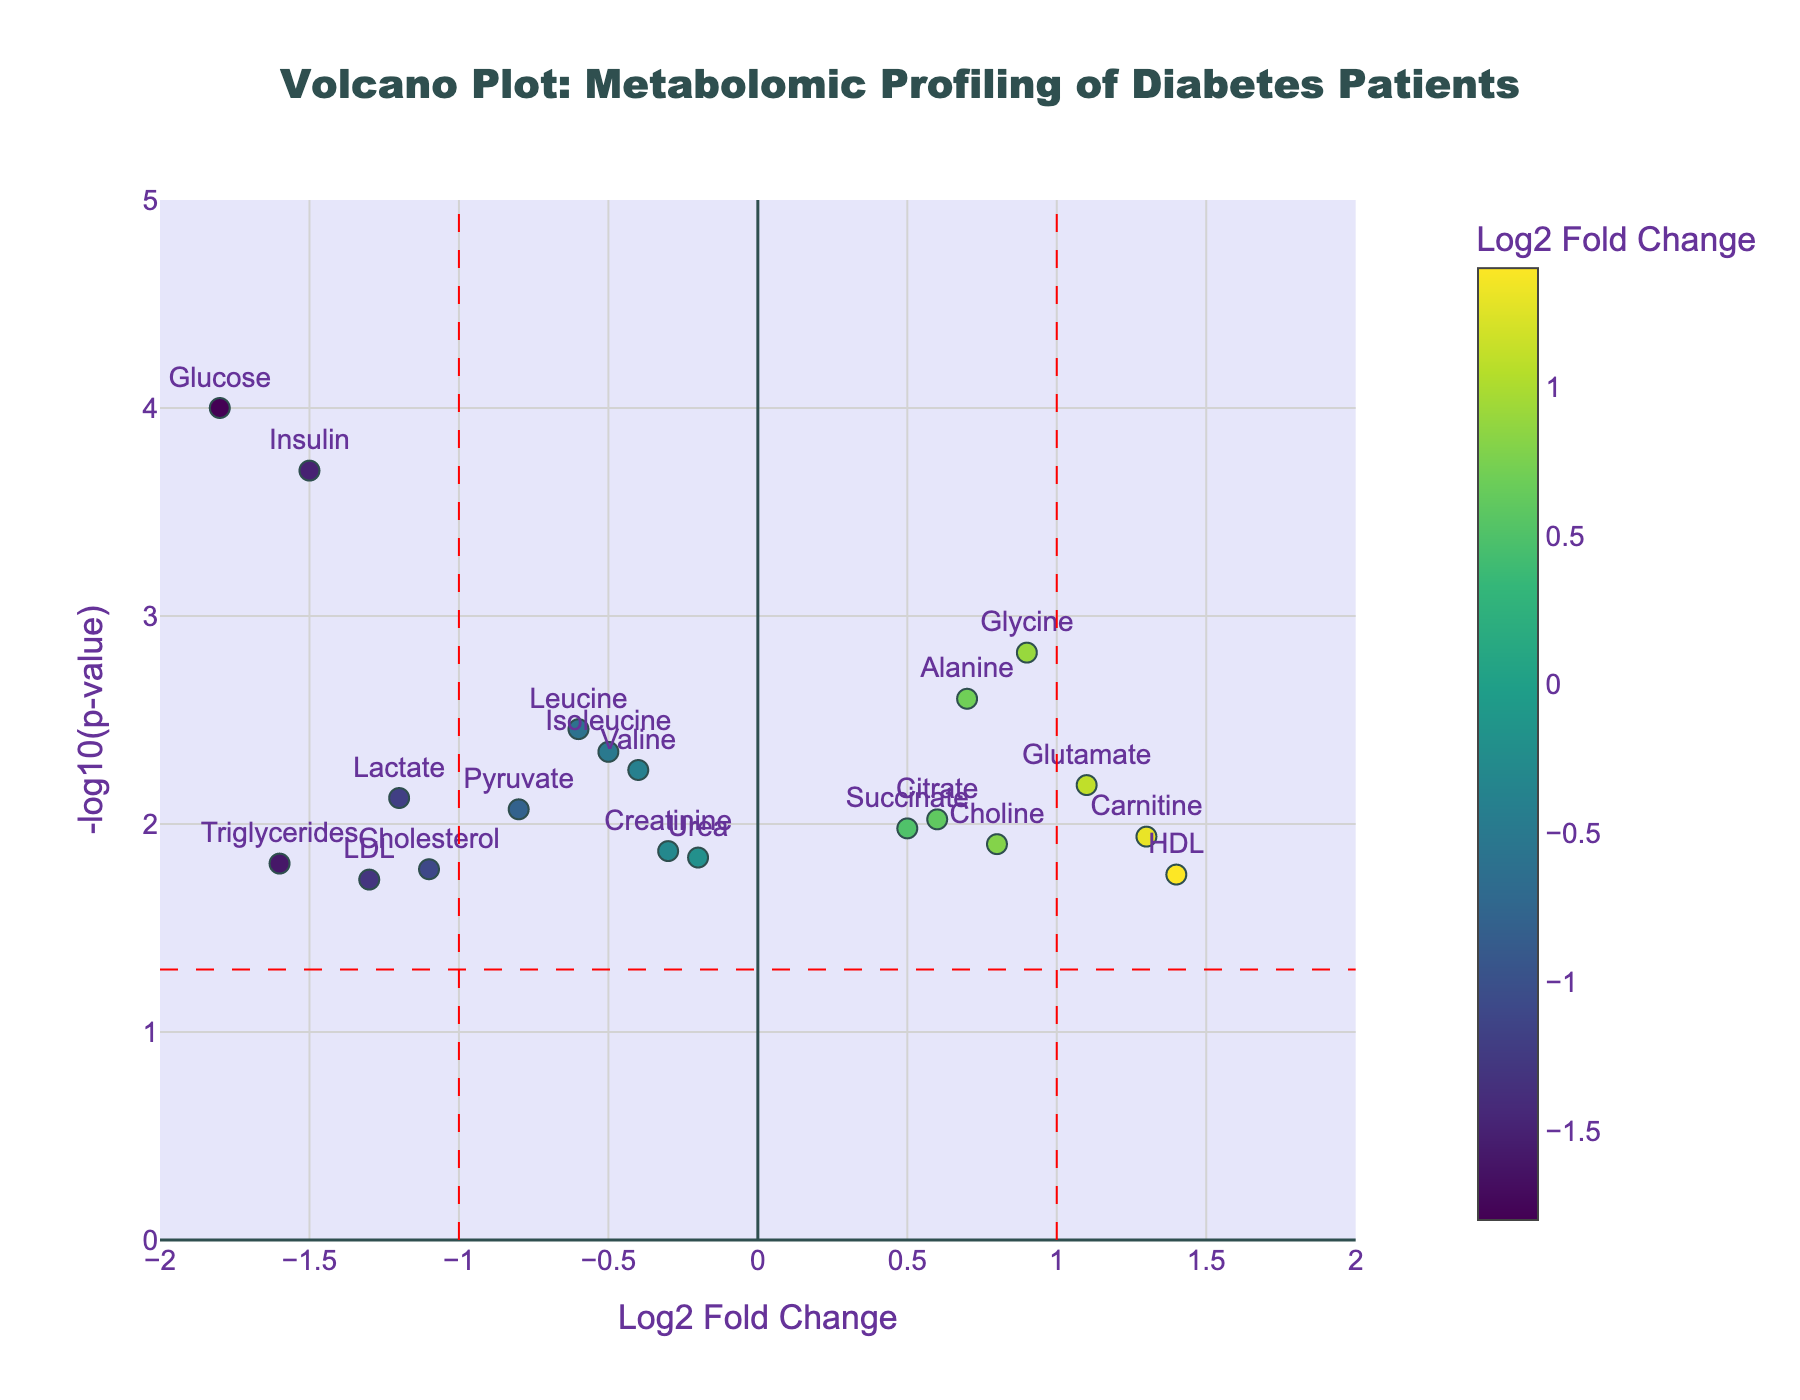What's the title of the plot? The title is written at the top-center of the figure. It reads "Volcano Plot: Metabolomic Profiling of Diabetes Patients".
Answer: Volcano Plot: Metabolomic Profiling of Diabetes Patients Which metabolite has the highest Log2 Fold Change? Examine the x-axis values and find the highest positive value for Log2 Fold Change. Carnitine has the highest Log2 Fold Change at 1.3.
Answer: Carnitine How many metabolites have a Log2 Fold Change less than -1? Identify the points on the left side of the figure below -1 on the x-axis. There are four metabolites: Glucose, Insulin, Triglycerides, and LDL.
Answer: 4 Which metabolite has the smallest p-value? The smallest p-value corresponds to the highest value on the y-axis. Glucose has the highest -log10(p-value) at 4.00, indicating the smallest p-value.
Answer: Glucose Name two metabolites with a Log2 Fold Change between -0.5 and 0.5. Locate the data points with Log2 Fold Change values between -0.5 and 0.5. Creatinine and Succinate fall into this range.
Answer: Creatinine and Succinate Compare the -log10(p-value) of Glucose and Choline. Which one is higher? Glucose has a -log10(p-value) of 4.00, while Choline has a -log10(p-value) of 1.90. Since 4.00 is greater than 1.90, Glucose has a higher -log10(p-value).
Answer: Glucose Which metabolite is closest to the vertical line representing Log2 Fold Change = 1? Identify the metabolite closest to the x=1 line. HDL is the closest to this vertical line.
Answer: HDL What is the Log2 Fold Change of Insulin? Locate the data point for Insulin and read its x-axis position. The Log2 Fold Change for Insulin is -1.5.
Answer: -1.5 How many metabolites have a -log10(p-value) greater than 2? Count the data points that lie above the y=2 line. Five metabolites have a -log10(p-value) greater than 2: Glucose, Insulin, Glycine, Alanine, and Leucine.
Answer: 5 Which metabolites exhibit both significant p-values (less than 0.05) and considerable fold changes (Log2 Fold Change greater than 1 or less than -1)? The significant p-values correspond to -log10(p-value) greater than 1.3. Considerable fold changes are less than -1 or greater than 1. Metabolites fitting these criteria are Glucose, Insulin, LDL, Triglycerides (all Log2FC < -1) and Carnitine, HDL (Log2FC > 1).
Answer: Glucose, Insulin, LDL, Triglycerides, Carnitine, HDL 